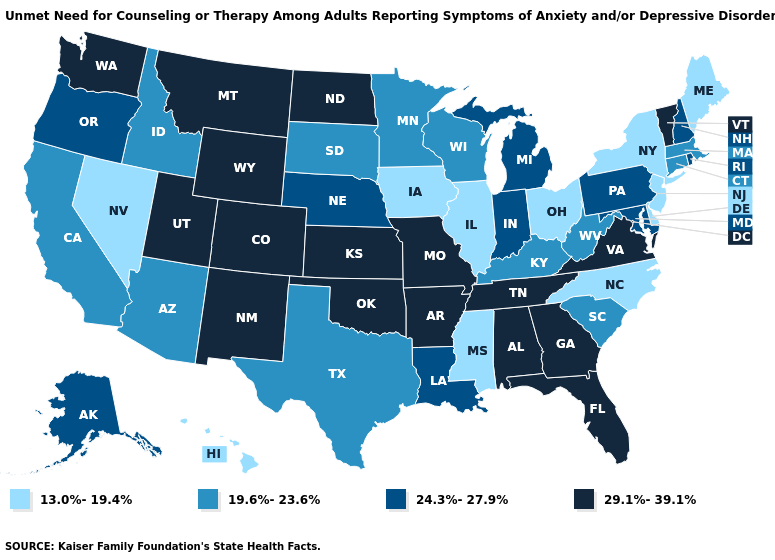Name the states that have a value in the range 24.3%-27.9%?
Quick response, please. Alaska, Indiana, Louisiana, Maryland, Michigan, Nebraska, New Hampshire, Oregon, Pennsylvania, Rhode Island. Does Missouri have the lowest value in the USA?
Be succinct. No. What is the value of North Carolina?
Keep it brief. 13.0%-19.4%. Among the states that border Tennessee , which have the lowest value?
Be succinct. Mississippi, North Carolina. Does North Dakota have the lowest value in the MidWest?
Be succinct. No. Name the states that have a value in the range 24.3%-27.9%?
Concise answer only. Alaska, Indiana, Louisiana, Maryland, Michigan, Nebraska, New Hampshire, Oregon, Pennsylvania, Rhode Island. Which states have the lowest value in the MidWest?
Quick response, please. Illinois, Iowa, Ohio. Does Delaware have the same value as Idaho?
Be succinct. No. What is the value of Delaware?
Answer briefly. 13.0%-19.4%. Among the states that border Missouri , does Iowa have the highest value?
Be succinct. No. Name the states that have a value in the range 13.0%-19.4%?
Give a very brief answer. Delaware, Hawaii, Illinois, Iowa, Maine, Mississippi, Nevada, New Jersey, New York, North Carolina, Ohio. Is the legend a continuous bar?
Concise answer only. No. Is the legend a continuous bar?
Short answer required. No. What is the value of Colorado?
Give a very brief answer. 29.1%-39.1%. Does North Dakota have the same value as Kansas?
Give a very brief answer. Yes. 